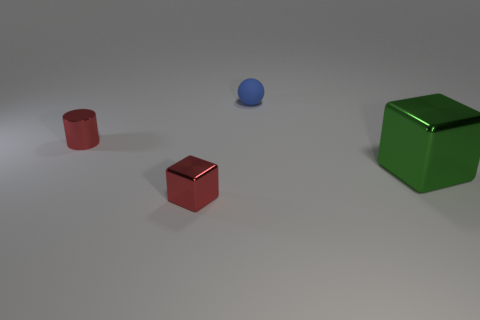Is there anything else that has the same material as the small ball?
Give a very brief answer. No. What shape is the small red metal object that is behind the metallic cube that is to the right of the tiny blue rubber thing?
Your answer should be very brief. Cylinder. Are there the same number of large green metal blocks that are behind the tiny blue matte thing and purple metallic objects?
Your answer should be compact. Yes. What is the material of the object that is on the left side of the small metal object in front of the object that is right of the small blue matte thing?
Keep it short and to the point. Metal. Is there a metal cube that has the same size as the matte sphere?
Your answer should be compact. Yes. The blue rubber object is what shape?
Make the answer very short. Sphere. What number of cubes are either small blue matte objects or tiny brown rubber things?
Give a very brief answer. 0. Are there the same number of tiny blue rubber balls behind the matte ball and big blocks to the right of the tiny block?
Provide a succinct answer. No. How many small things are on the left side of the block that is left of the shiny thing on the right side of the rubber thing?
Make the answer very short. 1. What shape is the small object that is the same color as the cylinder?
Give a very brief answer. Cube. 